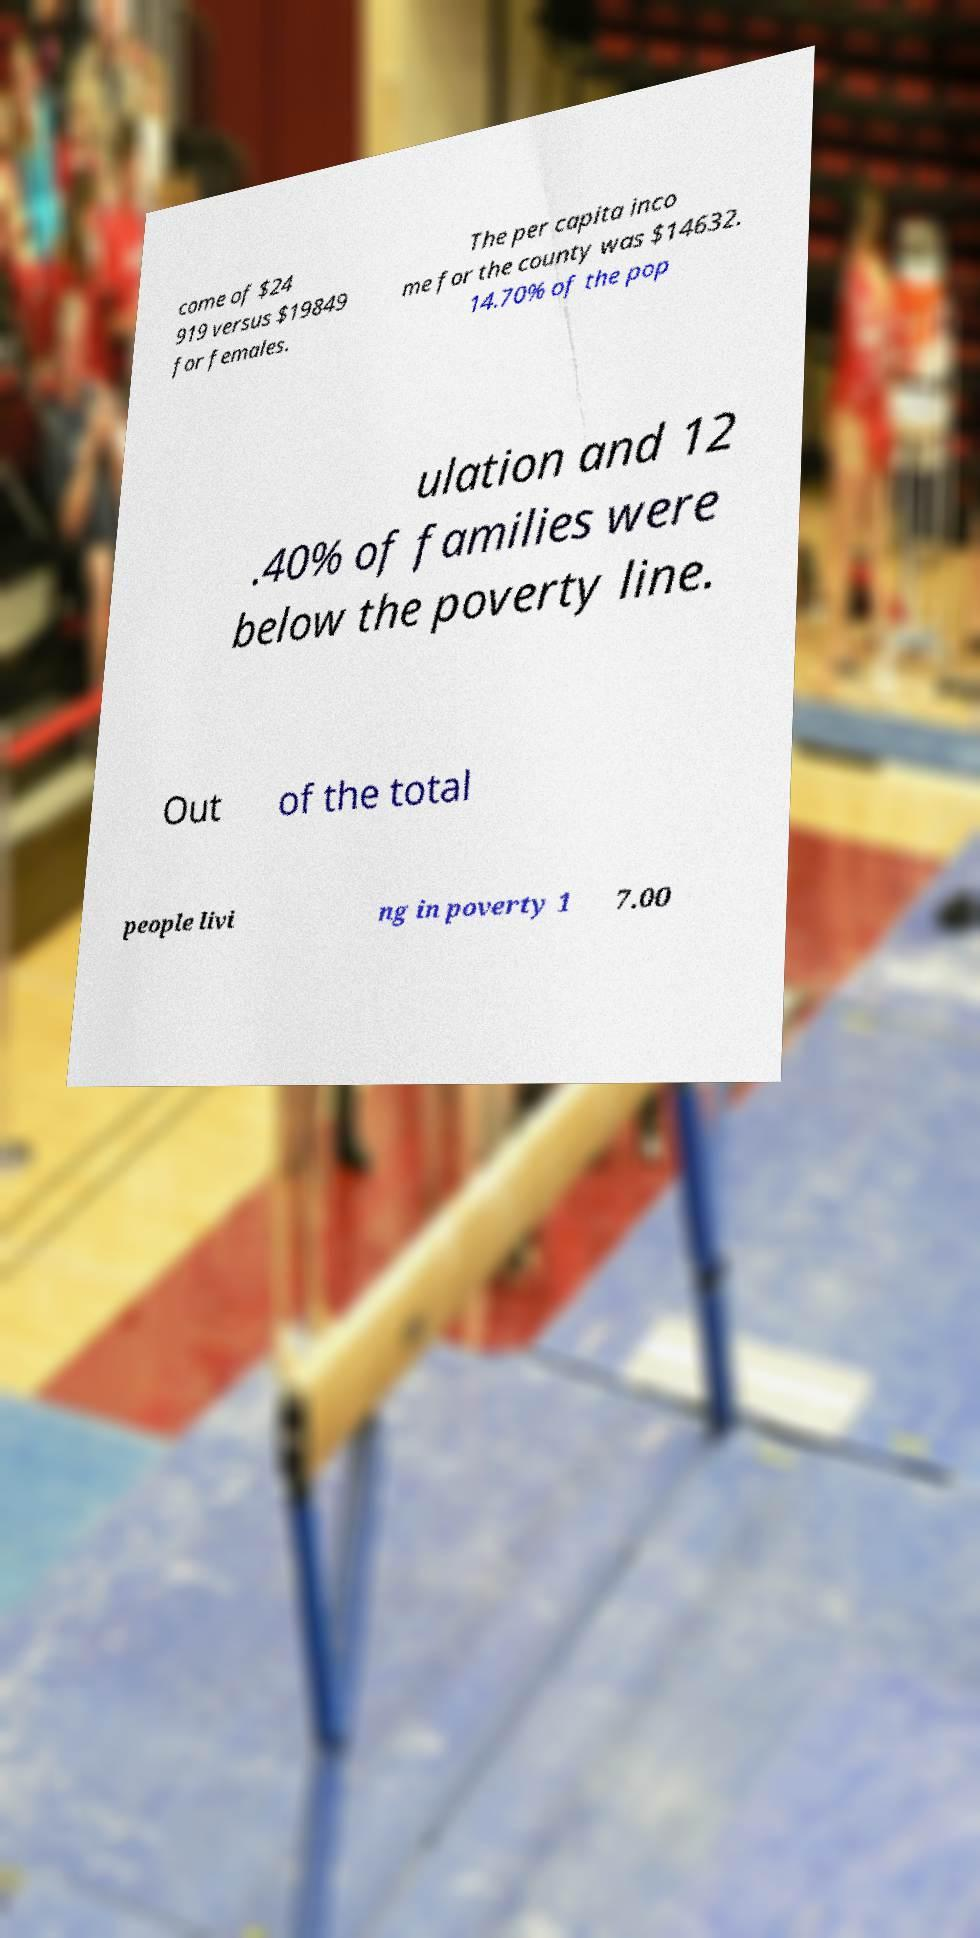Please identify and transcribe the text found in this image. come of $24 919 versus $19849 for females. The per capita inco me for the county was $14632. 14.70% of the pop ulation and 12 .40% of families were below the poverty line. Out of the total people livi ng in poverty 1 7.00 